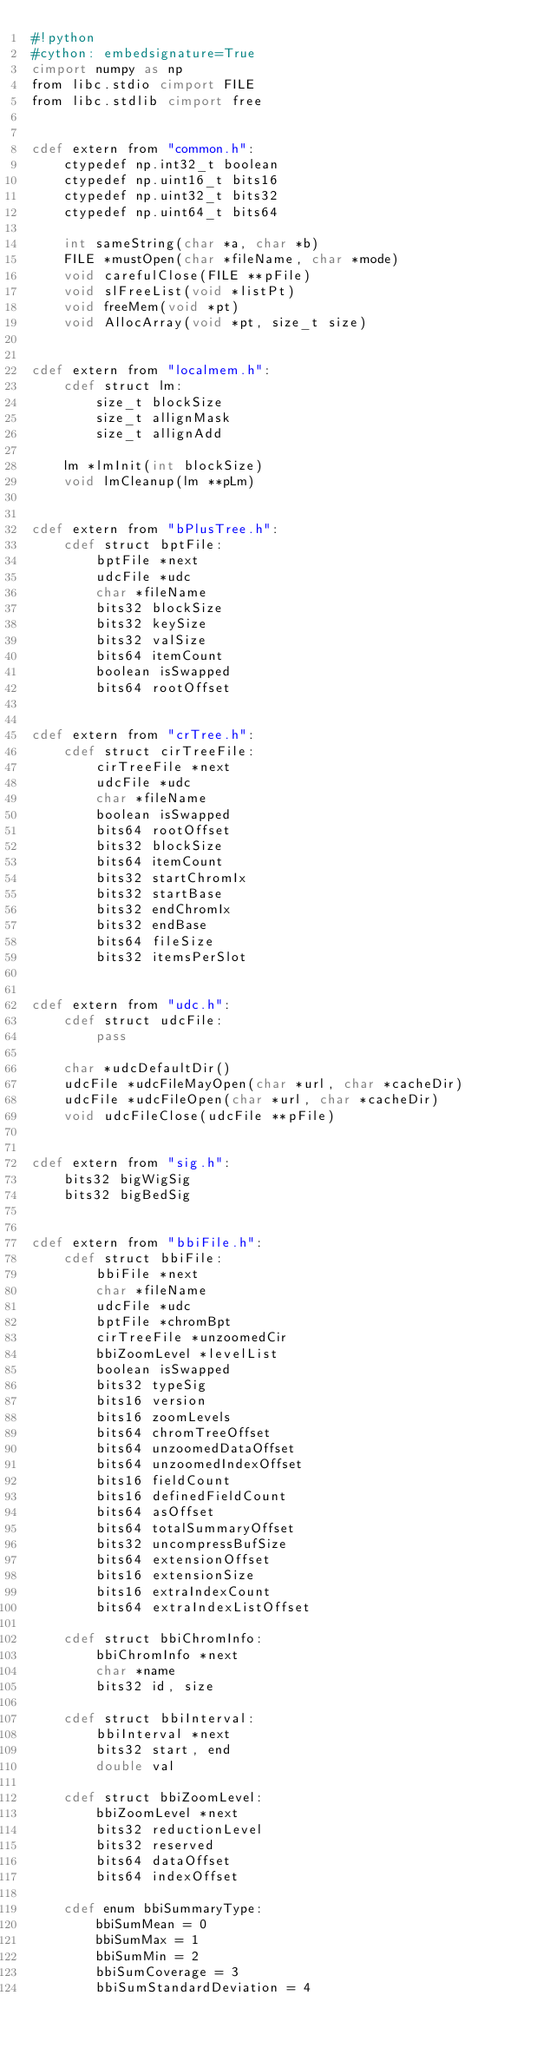<code> <loc_0><loc_0><loc_500><loc_500><_Cython_>#!python
#cython: embedsignature=True
cimport numpy as np
from libc.stdio cimport FILE
from libc.stdlib cimport free


cdef extern from "common.h":
    ctypedef np.int32_t boolean
    ctypedef np.uint16_t bits16
    ctypedef np.uint32_t bits32
    ctypedef np.uint64_t bits64

    int sameString(char *a, char *b)
    FILE *mustOpen(char *fileName, char *mode)
    void carefulClose(FILE **pFile)
    void slFreeList(void *listPt)
    void freeMem(void *pt)
    void AllocArray(void *pt, size_t size)


cdef extern from "localmem.h":
    cdef struct lm:
        size_t blockSize
        size_t allignMask
        size_t allignAdd

    lm *lmInit(int blockSize)
    void lmCleanup(lm **pLm)


cdef extern from "bPlusTree.h":
    cdef struct bptFile:
        bptFile *next
        udcFile *udc
        char *fileName
        bits32 blockSize
        bits32 keySize
        bits32 valSize
        bits64 itemCount
        boolean isSwapped
        bits64 rootOffset


cdef extern from "crTree.h":
    cdef struct cirTreeFile:
        cirTreeFile *next
        udcFile *udc
        char *fileName
        boolean isSwapped
        bits64 rootOffset
        bits32 blockSize
        bits64 itemCount
        bits32 startChromIx
        bits32 startBase
        bits32 endChromIx
        bits32 endBase
        bits64 fileSize
        bits32 itemsPerSlot


cdef extern from "udc.h":
    cdef struct udcFile:
        pass

    char *udcDefaultDir()
    udcFile *udcFileMayOpen(char *url, char *cacheDir)
    udcFile *udcFileOpen(char *url, char *cacheDir)
    void udcFileClose(udcFile **pFile)


cdef extern from "sig.h":
    bits32 bigWigSig
    bits32 bigBedSig


cdef extern from "bbiFile.h":
    cdef struct bbiFile:
        bbiFile *next
        char *fileName
        udcFile *udc
        bptFile *chromBpt
        cirTreeFile *unzoomedCir
        bbiZoomLevel *levelList
        boolean isSwapped
        bits32 typeSig
        bits16 version
        bits16 zoomLevels
        bits64 chromTreeOffset
        bits64 unzoomedDataOffset
        bits64 unzoomedIndexOffset
        bits16 fieldCount
        bits16 definedFieldCount
        bits64 asOffset
        bits64 totalSummaryOffset
        bits32 uncompressBufSize
        bits64 extensionOffset
        bits16 extensionSize
        bits16 extraIndexCount
        bits64 extraIndexListOffset

    cdef struct bbiChromInfo:
        bbiChromInfo *next
        char *name
        bits32 id, size

    cdef struct bbiInterval:
        bbiInterval *next
        bits32 start, end
        double val

    cdef struct bbiZoomLevel:
        bbiZoomLevel *next
        bits32 reductionLevel
        bits32 reserved
        bits64 dataOffset
        bits64 indexOffset

    cdef enum bbiSummaryType:
        bbiSumMean = 0
        bbiSumMax = 1
        bbiSumMin = 2
        bbiSumCoverage = 3
        bbiSumStandardDeviation = 4
</code> 